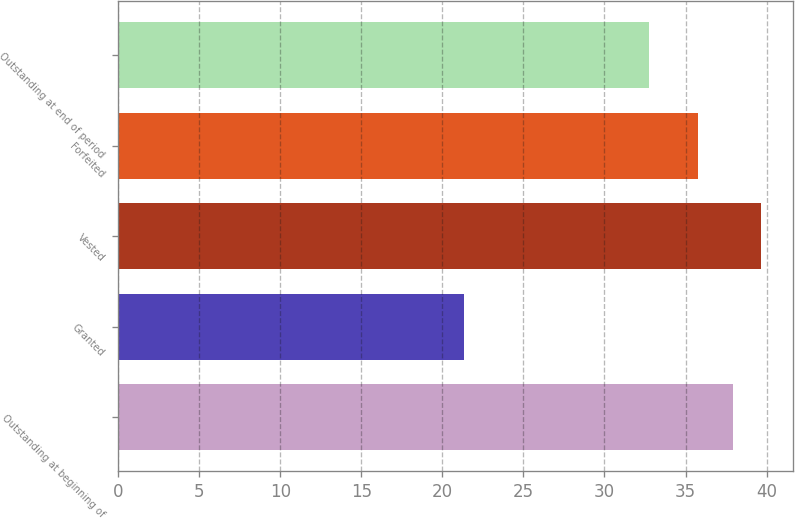<chart> <loc_0><loc_0><loc_500><loc_500><bar_chart><fcel>Outstanding at beginning of<fcel>Granted<fcel>Vested<fcel>Forfeited<fcel>Outstanding at end of period<nl><fcel>37.91<fcel>21.36<fcel>39.63<fcel>35.74<fcel>32.72<nl></chart> 